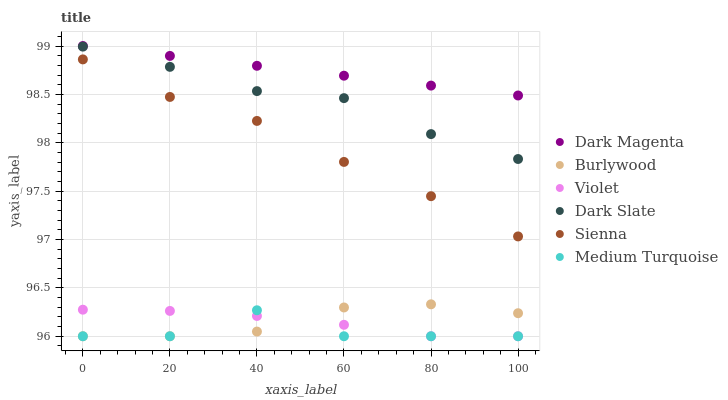Does Medium Turquoise have the minimum area under the curve?
Answer yes or no. Yes. Does Dark Magenta have the maximum area under the curve?
Answer yes or no. Yes. Does Burlywood have the minimum area under the curve?
Answer yes or no. No. Does Burlywood have the maximum area under the curve?
Answer yes or no. No. Is Dark Magenta the smoothest?
Answer yes or no. Yes. Is Medium Turquoise the roughest?
Answer yes or no. Yes. Is Burlywood the smoothest?
Answer yes or no. No. Is Burlywood the roughest?
Answer yes or no. No. Does Burlywood have the lowest value?
Answer yes or no. Yes. Does Sienna have the lowest value?
Answer yes or no. No. Does Dark Magenta have the highest value?
Answer yes or no. Yes. Does Burlywood have the highest value?
Answer yes or no. No. Is Burlywood less than Dark Slate?
Answer yes or no. Yes. Is Dark Slate greater than Violet?
Answer yes or no. Yes. Does Burlywood intersect Medium Turquoise?
Answer yes or no. Yes. Is Burlywood less than Medium Turquoise?
Answer yes or no. No. Is Burlywood greater than Medium Turquoise?
Answer yes or no. No. Does Burlywood intersect Dark Slate?
Answer yes or no. No. 